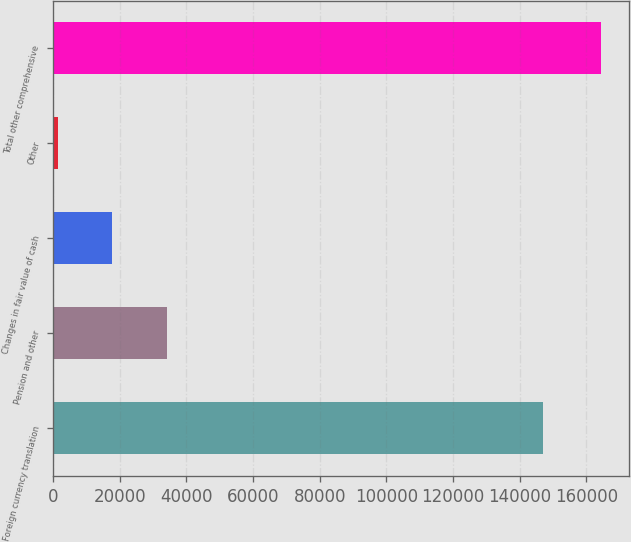Convert chart to OTSL. <chart><loc_0><loc_0><loc_500><loc_500><bar_chart><fcel>Foreign currency translation<fcel>Pension and other<fcel>Changes in fair value of cash<fcel>Other<fcel>Total other comprehensive<nl><fcel>147056<fcel>34101.4<fcel>17793.2<fcel>1485<fcel>164567<nl></chart> 